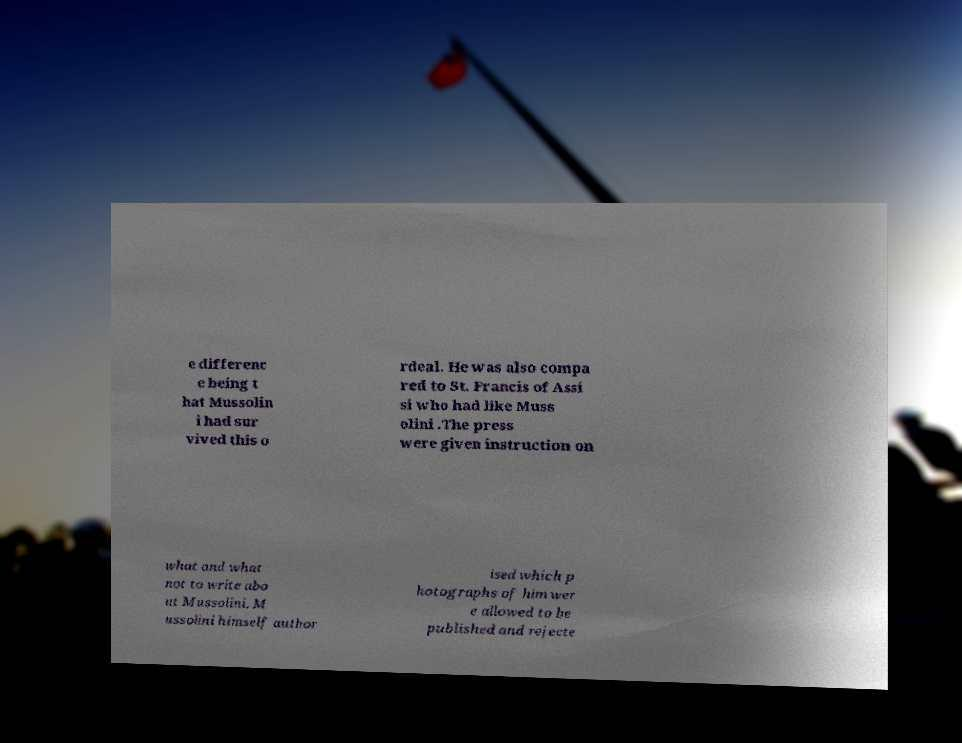For documentation purposes, I need the text within this image transcribed. Could you provide that? e differenc e being t hat Mussolin i had sur vived this o rdeal. He was also compa red to St. Francis of Assi si who had like Muss olini .The press were given instruction on what and what not to write abo ut Mussolini. M ussolini himself author ised which p hotographs of him wer e allowed to be published and rejecte 